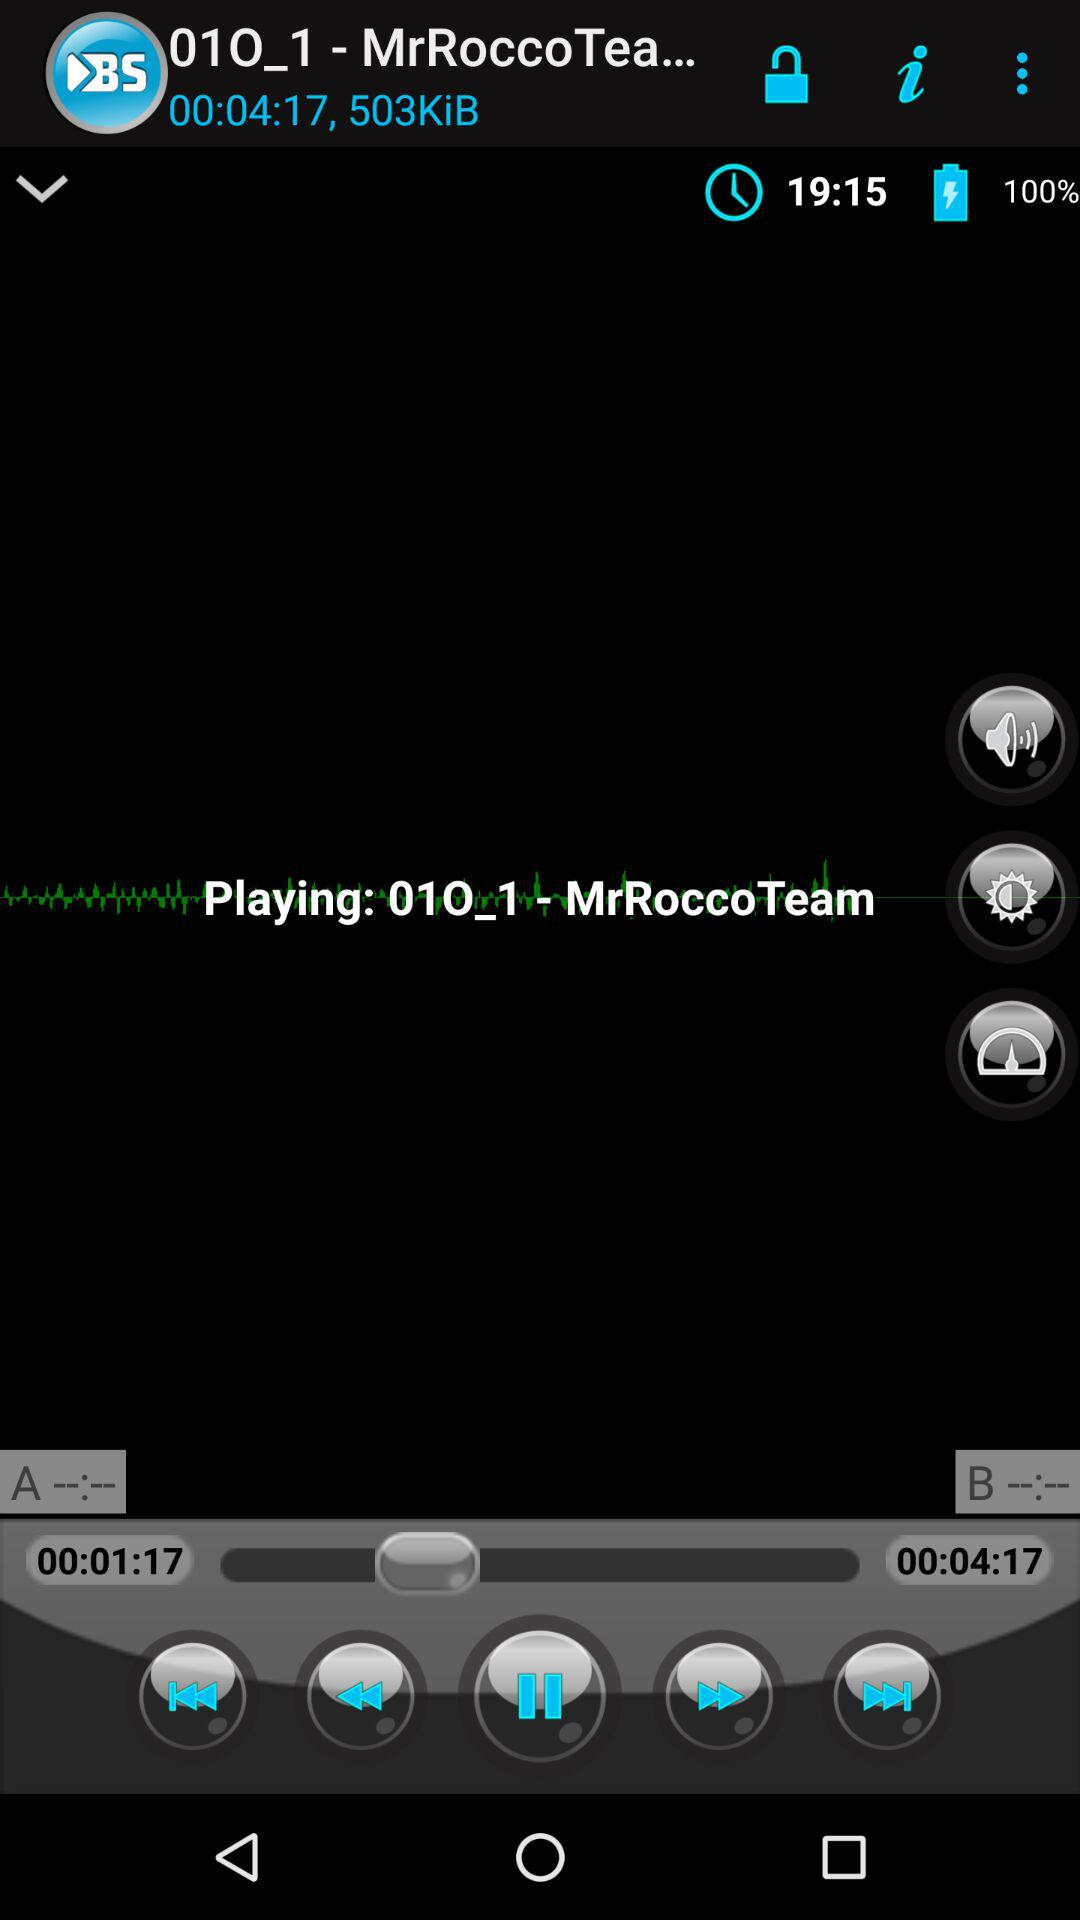What is the time duration of the audio playing? The time duration is 4 minutes and 17 seconds. 